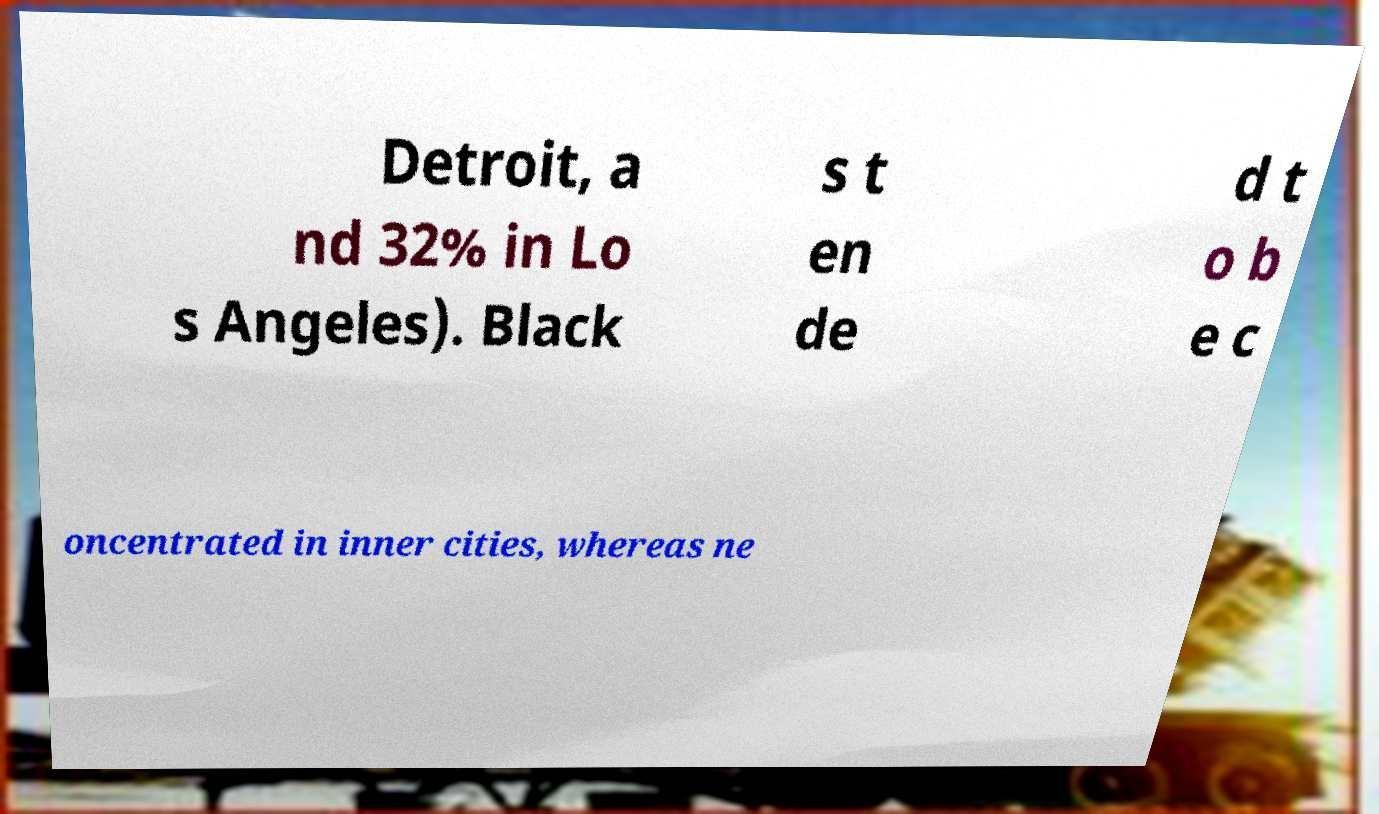Could you extract and type out the text from this image? Detroit, a nd 32% in Lo s Angeles). Black s t en de d t o b e c oncentrated in inner cities, whereas ne 